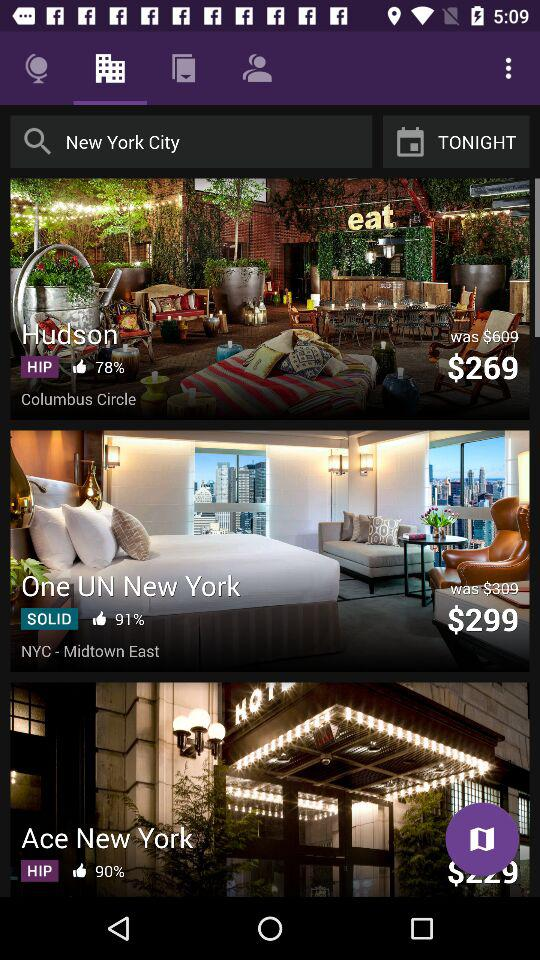What is the current price of the "One UN New York" hotel? The current price is $299. 